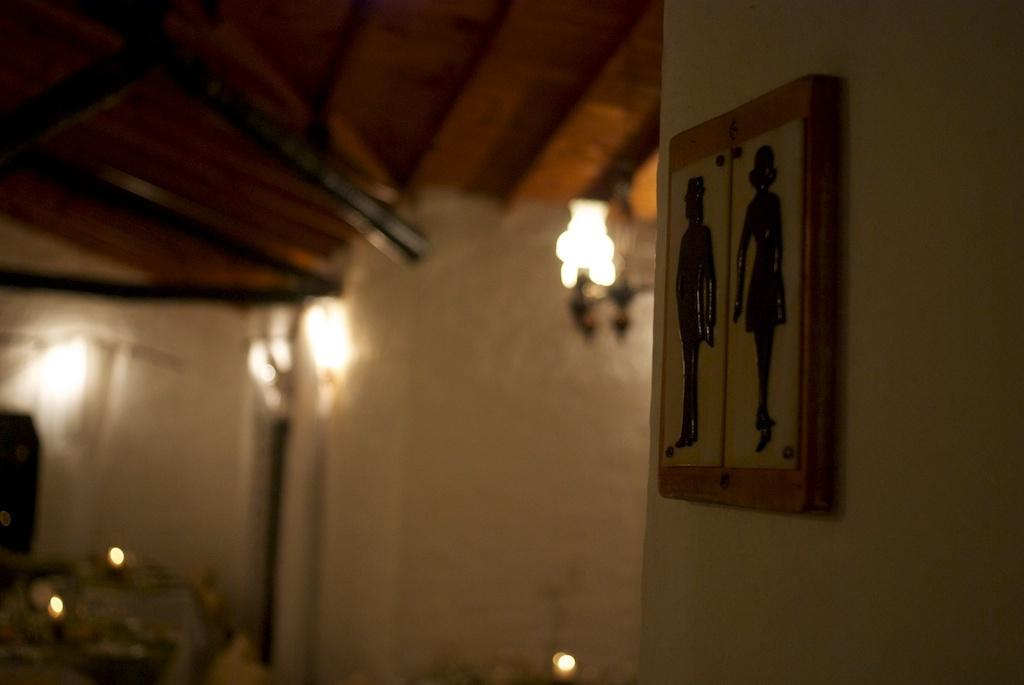What is the main object in the image? There is a frame in the image. Where is the frame located? The frame is kept on a wall. Can you describe the background of the wall? The background of the wall is blurred. What direction is the ship sailing in the image? There is no ship present in the image. What type of recess is visible in the image? There is no recess present in the image. 